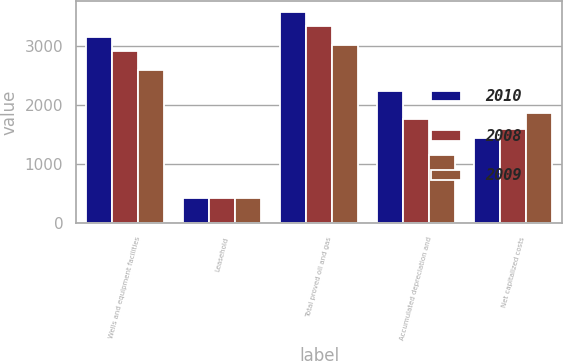Convert chart to OTSL. <chart><loc_0><loc_0><loc_500><loc_500><stacked_bar_chart><ecel><fcel>Wells and equipment facilities<fcel>Leasehold<fcel>Total proved oil and gas<fcel>Accumulated depreciation and<fcel>Net capitalized costs<nl><fcel>2010<fcel>3158.8<fcel>433.1<fcel>3591.9<fcel>2235.4<fcel>1444.8<nl><fcel>2008<fcel>2920.7<fcel>433.5<fcel>3354.2<fcel>1764<fcel>1600.4<nl><fcel>2009<fcel>2595.4<fcel>429.8<fcel>3025.2<fcel>1155.6<fcel>1869.6<nl></chart> 